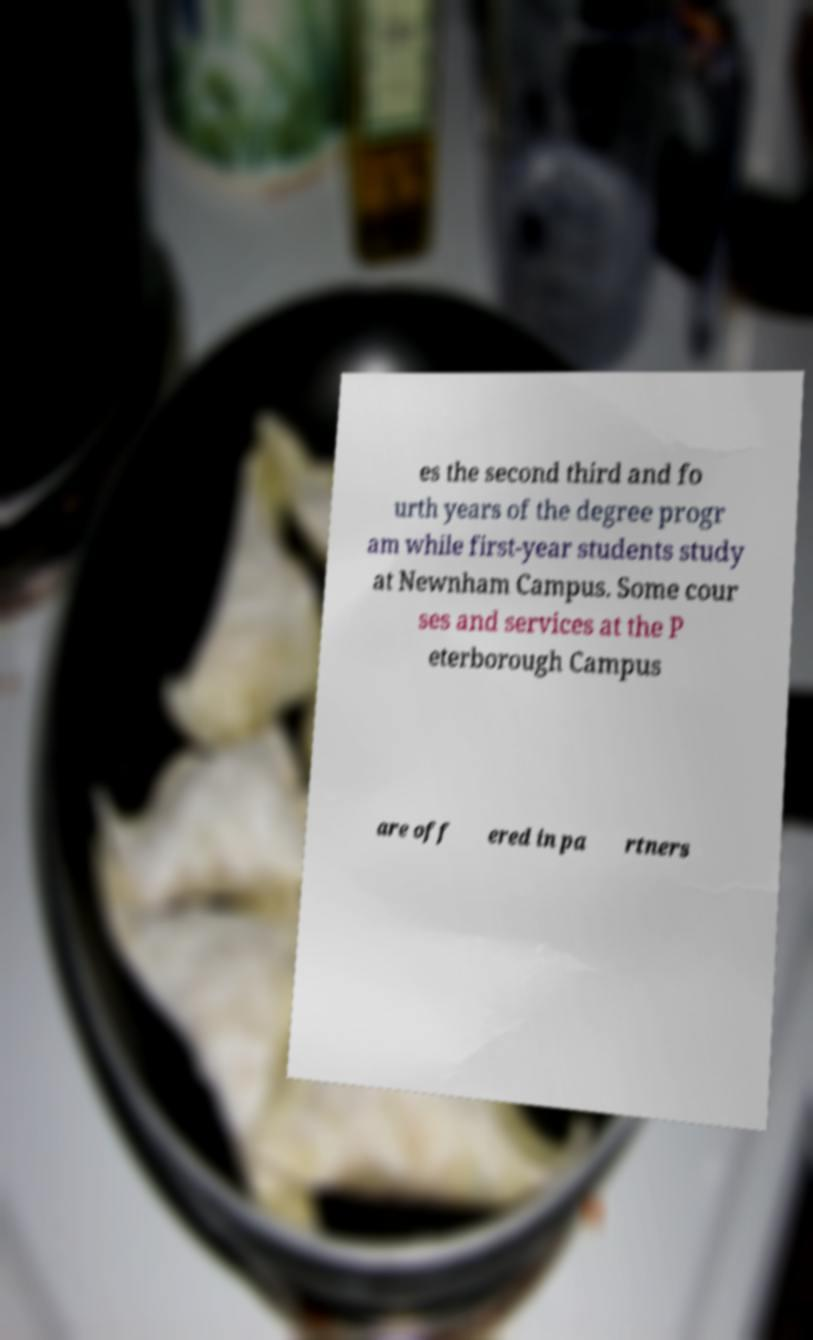For documentation purposes, I need the text within this image transcribed. Could you provide that? es the second third and fo urth years of the degree progr am while first-year students study at Newnham Campus. Some cour ses and services at the P eterborough Campus are off ered in pa rtners 